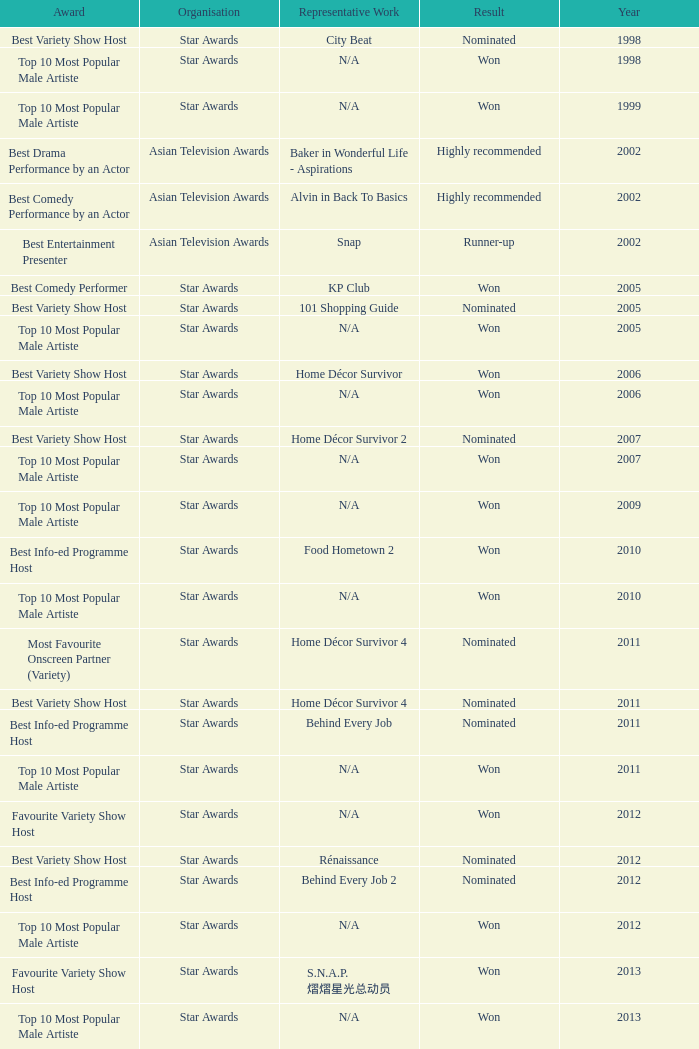What is the organisation in 2011 that was nominated and the award of best info-ed programme host? Star Awards. Help me parse the entirety of this table. {'header': ['Award', 'Organisation', 'Representative Work', 'Result', 'Year'], 'rows': [['Best Variety Show Host', 'Star Awards', 'City Beat', 'Nominated', '1998'], ['Top 10 Most Popular Male Artiste', 'Star Awards', 'N/A', 'Won', '1998'], ['Top 10 Most Popular Male Artiste', 'Star Awards', 'N/A', 'Won', '1999'], ['Best Drama Performance by an Actor', 'Asian Television Awards', 'Baker in Wonderful Life - Aspirations', 'Highly recommended', '2002'], ['Best Comedy Performance by an Actor', 'Asian Television Awards', 'Alvin in Back To Basics', 'Highly recommended', '2002'], ['Best Entertainment Presenter', 'Asian Television Awards', 'Snap', 'Runner-up', '2002'], ['Best Comedy Performer', 'Star Awards', 'KP Club', 'Won', '2005'], ['Best Variety Show Host', 'Star Awards', '101 Shopping Guide', 'Nominated', '2005'], ['Top 10 Most Popular Male Artiste', 'Star Awards', 'N/A', 'Won', '2005'], ['Best Variety Show Host', 'Star Awards', 'Home Décor Survivor', 'Won', '2006'], ['Top 10 Most Popular Male Artiste', 'Star Awards', 'N/A', 'Won', '2006'], ['Best Variety Show Host', 'Star Awards', 'Home Décor Survivor 2', 'Nominated', '2007'], ['Top 10 Most Popular Male Artiste', 'Star Awards', 'N/A', 'Won', '2007'], ['Top 10 Most Popular Male Artiste', 'Star Awards', 'N/A', 'Won', '2009'], ['Best Info-ed Programme Host', 'Star Awards', 'Food Hometown 2', 'Won', '2010'], ['Top 10 Most Popular Male Artiste', 'Star Awards', 'N/A', 'Won', '2010'], ['Most Favourite Onscreen Partner (Variety)', 'Star Awards', 'Home Décor Survivor 4', 'Nominated', '2011'], ['Best Variety Show Host', 'Star Awards', 'Home Décor Survivor 4', 'Nominated', '2011'], ['Best Info-ed Programme Host', 'Star Awards', 'Behind Every Job', 'Nominated', '2011'], ['Top 10 Most Popular Male Artiste', 'Star Awards', 'N/A', 'Won', '2011'], ['Favourite Variety Show Host', 'Star Awards', 'N/A', 'Won', '2012'], ['Best Variety Show Host', 'Star Awards', 'Rénaissance', 'Nominated', '2012'], ['Best Info-ed Programme Host', 'Star Awards', 'Behind Every Job 2', 'Nominated', '2012'], ['Top 10 Most Popular Male Artiste', 'Star Awards', 'N/A', 'Won', '2012'], ['Favourite Variety Show Host', 'Star Awards', 'S.N.A.P. 熠熠星光总动员', 'Won', '2013'], ['Top 10 Most Popular Male Artiste', 'Star Awards', 'N/A', 'Won', '2013'], ['Best Info-Ed Programme Host', 'Star Awards', 'Makan Unlimited', 'Nominated', '2013'], ['Best Variety Show Host', 'Star Awards', 'Jobs Around The World', 'Nominated', '2013']]} 